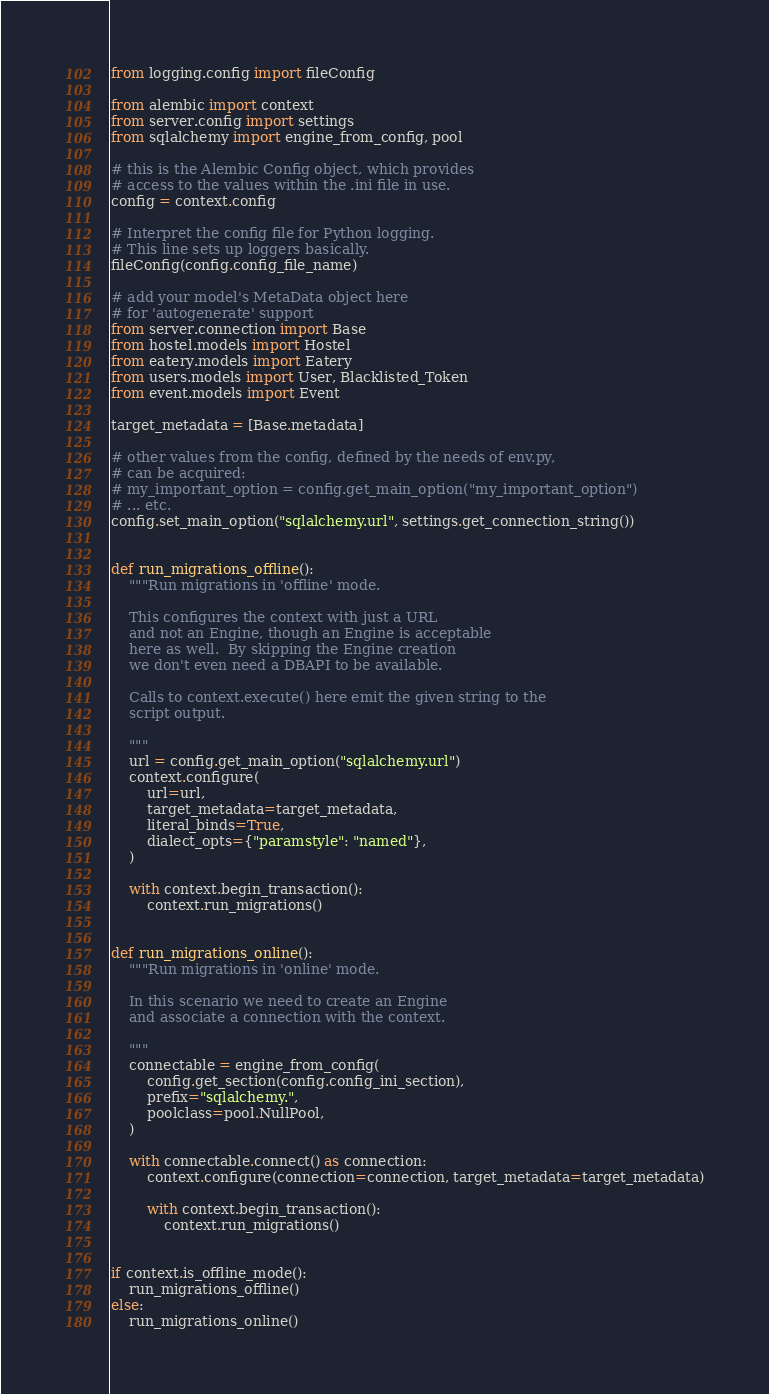Convert code to text. <code><loc_0><loc_0><loc_500><loc_500><_Python_>from logging.config import fileConfig

from alembic import context
from server.config import settings
from sqlalchemy import engine_from_config, pool

# this is the Alembic Config object, which provides
# access to the values within the .ini file in use.
config = context.config

# Interpret the config file for Python logging.
# This line sets up loggers basically.
fileConfig(config.config_file_name)

# add your model's MetaData object here
# for 'autogenerate' support
from server.connection import Base
from hostel.models import Hostel
from eatery.models import Eatery
from users.models import User, Blacklisted_Token
from event.models import Event

target_metadata = [Base.metadata]

# other values from the config, defined by the needs of env.py,
# can be acquired:
# my_important_option = config.get_main_option("my_important_option")
# ... etc.
config.set_main_option("sqlalchemy.url", settings.get_connection_string())


def run_migrations_offline():
    """Run migrations in 'offline' mode.

    This configures the context with just a URL
    and not an Engine, though an Engine is acceptable
    here as well.  By skipping the Engine creation
    we don't even need a DBAPI to be available.

    Calls to context.execute() here emit the given string to the
    script output.

    """
    url = config.get_main_option("sqlalchemy.url")
    context.configure(
        url=url,
        target_metadata=target_metadata,
        literal_binds=True,
        dialect_opts={"paramstyle": "named"},
    )

    with context.begin_transaction():
        context.run_migrations()


def run_migrations_online():
    """Run migrations in 'online' mode.

    In this scenario we need to create an Engine
    and associate a connection with the context.

    """
    connectable = engine_from_config(
        config.get_section(config.config_ini_section),
        prefix="sqlalchemy.",
        poolclass=pool.NullPool,
    )

    with connectable.connect() as connection:
        context.configure(connection=connection, target_metadata=target_metadata)

        with context.begin_transaction():
            context.run_migrations()


if context.is_offline_mode():
    run_migrations_offline()
else:
    run_migrations_online()
</code> 